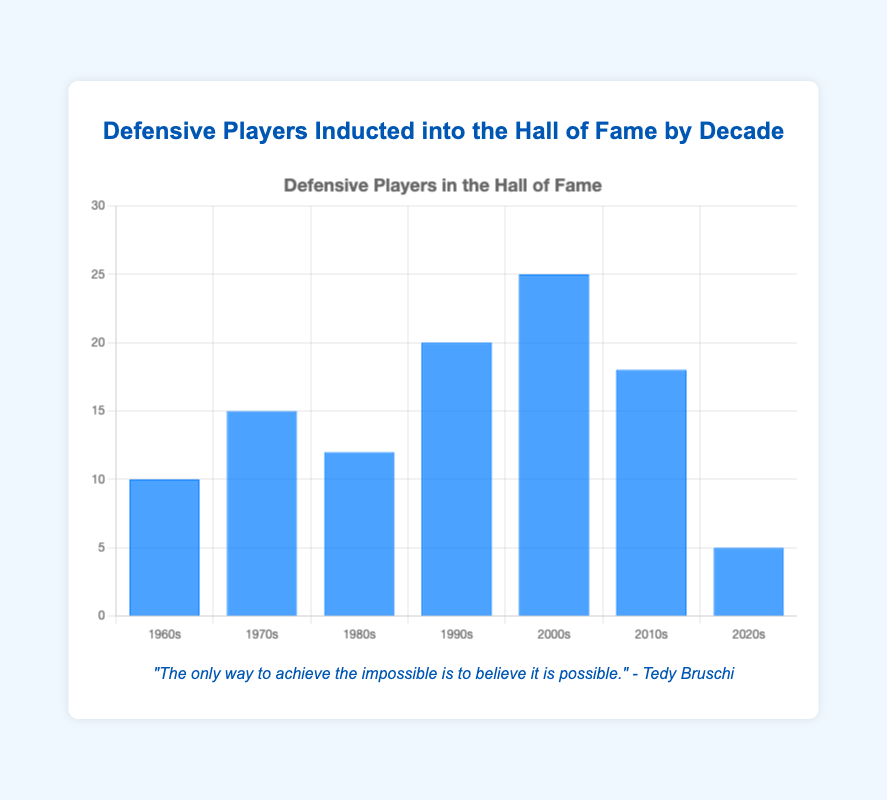Which decade had the highest number of defensive players inducted into the Hall of Fame? By looking at the height of the bars, the decade with the highest number is the 2000s with 25 defensive players.
Answer: 2000s Which decade had the fewest defensive players inducted into the Hall of Fame? By looking at the height of the bars, the decade with the fewest number of defensive players is the 2020s with 5 players.
Answer: 2020s How many more defensive players were inducted in the 2000s compared to the 1960s? The number of defensive players inducted in the 2000s is 25, while in the 1960s it is 10. The difference is 25 - 10.
Answer: 15 What is the average number of defensive players inducted per decade in the 1970s, 1980s, and 1990s? Add the numbers for the 1970s (15), 1980s (12), and 1990s (20), then divide by 3. (15 + 12 + 20) / 3 = 47 / 3 ≈ 15.67
Answer: 15.67 Which two decades combined have the same number of inductees as the 2000s? The 1990s had 20 inductees, and the 1960s had 10, which sum up to 30, but this is not correct. Instead, the 1990s (20) and the 2010s (18) combined to have more than the 2000s. Therefore, there's no pair that sums to exactly 25.
Answer: None Which decade had more inductees: the 1980s or the 2010s? By looking at the heights of the bars, the 2010s had 18 defensive players while the 1980s had 12.
Answer: 2010s What's the sum of defensive players inducted in the decades 1960s, 1970s, and 1980s? Add the defensive players for the 1960s (10), 1970s (15), and 1980s (12). 10 + 15 + 12 = 37
Answer: 37 If you combine the decades 1980s and 1990s, how many defensive players were inducted? The 1980s had 12 and the 1990s had 20. Combined, that is 12 + 20 = 32
Answer: 32 What's the total number of defensive players inducted into the Hall of Fame from 1960s to 2020s? Add the inductees from all the decades: 10 (1960s) + 15 (1970s) + 12 (1980s) + 20 (1990s) + 25 (2000s) + 18 (2010s) + 5 (2020s). 10 + 15 + 12 + 20 + 25 + 18 + 5 = 105
Answer: 105 How does the number of defensive players inducted in the 1990s compare to the average of all decades? Average of all decades: (10 + 15 + 12 + 20 + 25 + 18 + 5) / 7 ≈ 105 / 7 ≈ 15. The 1990s had 20 players, which is greater than the average.
Answer: Greater Which decade saw a rise in the number of inducted players right after a drop? The number had dropped from 2000s (25) to 2010s (18), then increased in the 2020s (5), which does not meet the criteria. Thus, no decade meets these criteria perfectly from the given data.
Answer: None 